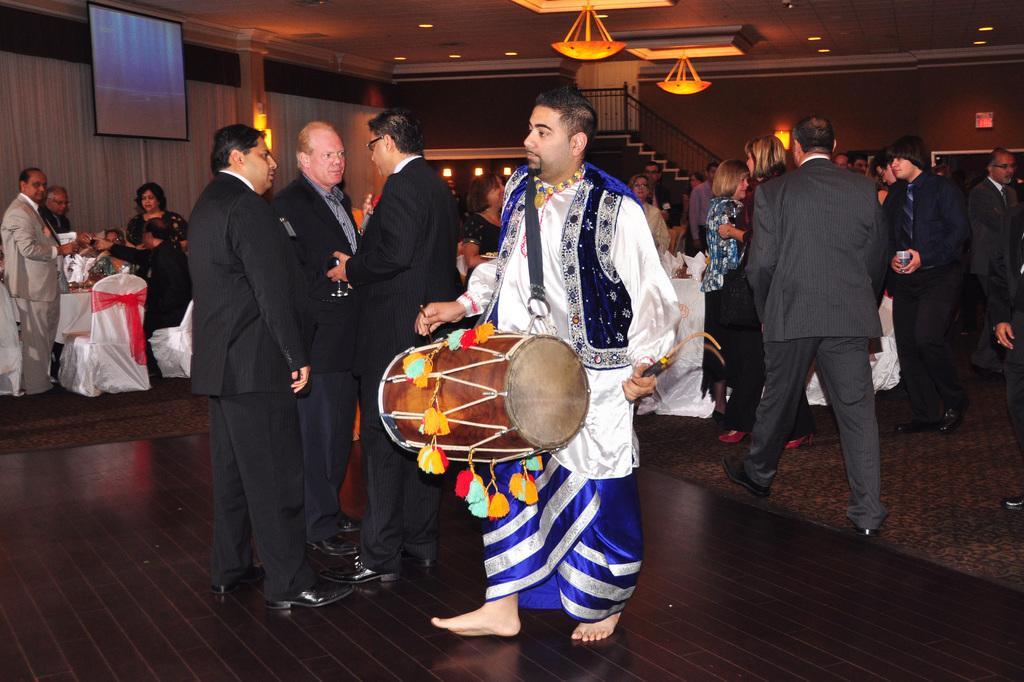How would you summarize this image in a sentence or two? Here we see a group of people standing and a man playing drums 